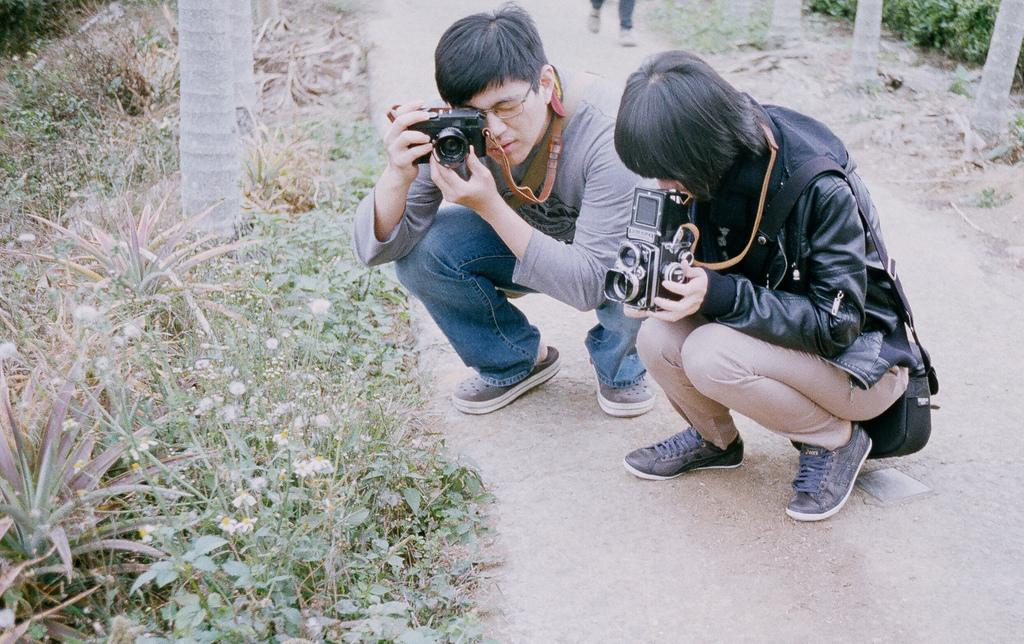How many people are in the image? There are two persons in the image. What are the two persons doing? The two persons are taking pictures. What are the subjects of the pictures they are taking? The subjects of the pictures are plants. Where are the plants located? The plants are located on the side of the road. What can be seen on either side of the road? There are trees on either side of the road. Can you see any development projects happening in the image? There is no indication of any development projects in the image; it primarily features two people taking pictures of plants on the side of the road. Is there an airplane visible in the image? No, there is no airplane present in the image. 